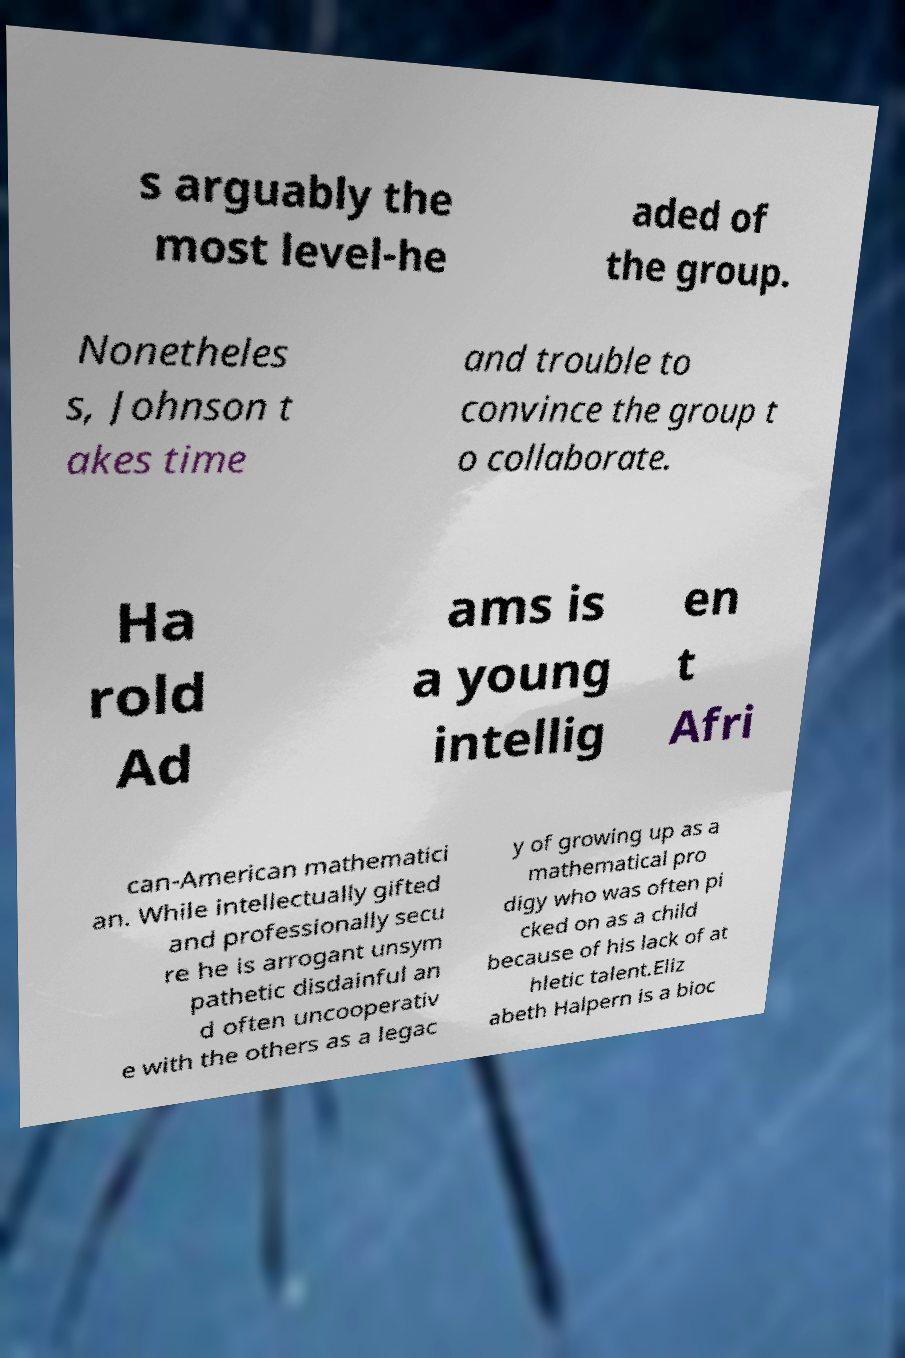There's text embedded in this image that I need extracted. Can you transcribe it verbatim? s arguably the most level-he aded of the group. Nonetheles s, Johnson t akes time and trouble to convince the group t o collaborate. Ha rold Ad ams is a young intellig en t Afri can-American mathematici an. While intellectually gifted and professionally secu re he is arrogant unsym pathetic disdainful an d often uncooperativ e with the others as a legac y of growing up as a mathematical pro digy who was often pi cked on as a child because of his lack of at hletic talent.Eliz abeth Halpern is a bioc 